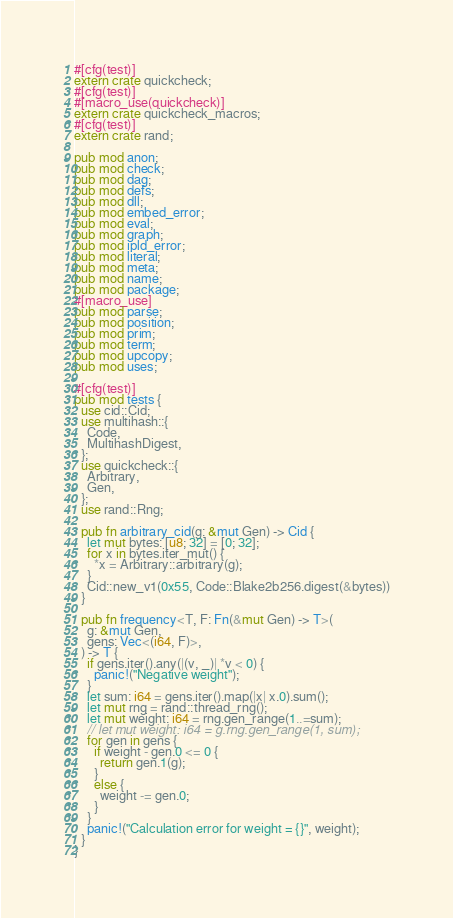Convert code to text. <code><loc_0><loc_0><loc_500><loc_500><_Rust_>#[cfg(test)]
extern crate quickcheck;
#[cfg(test)]
#[macro_use(quickcheck)]
extern crate quickcheck_macros;
#[cfg(test)]
extern crate rand;

pub mod anon;
pub mod check;
pub mod dag;
pub mod defs;
pub mod dll;
pub mod embed_error;
pub mod eval;
pub mod graph;
pub mod ipld_error;
pub mod literal;
pub mod meta;
pub mod name;
pub mod package;
#[macro_use]
pub mod parse;
pub mod position;
pub mod prim;
pub mod term;
pub mod upcopy;
pub mod uses;

#[cfg(test)]
pub mod tests {
  use cid::Cid;
  use multihash::{
    Code,
    MultihashDigest,
  };
  use quickcheck::{
    Arbitrary,
    Gen,
  };
  use rand::Rng;

  pub fn arbitrary_cid(g: &mut Gen) -> Cid {
    let mut bytes: [u8; 32] = [0; 32];
    for x in bytes.iter_mut() {
      *x = Arbitrary::arbitrary(g);
    }
    Cid::new_v1(0x55, Code::Blake2b256.digest(&bytes))
  }

  pub fn frequency<T, F: Fn(&mut Gen) -> T>(
    g: &mut Gen,
    gens: Vec<(i64, F)>,
  ) -> T {
    if gens.iter().any(|(v, _)| *v < 0) {
      panic!("Negative weight");
    }
    let sum: i64 = gens.iter().map(|x| x.0).sum();
    let mut rng = rand::thread_rng();
    let mut weight: i64 = rng.gen_range(1..=sum);
    // let mut weight: i64 = g.rng.gen_range(1, sum);
    for gen in gens {
      if weight - gen.0 <= 0 {
        return gen.1(g);
      }
      else {
        weight -= gen.0;
      }
    }
    panic!("Calculation error for weight = {}", weight);
  }
}
</code> 